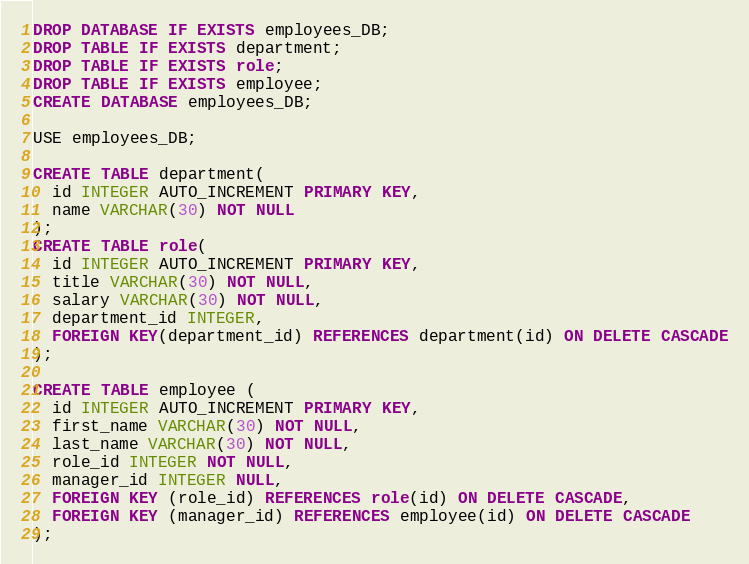<code> <loc_0><loc_0><loc_500><loc_500><_SQL_>DROP DATABASE IF EXISTS employees_DB;
DROP TABLE IF EXISTS department;
DROP TABLE IF EXISTS role;
DROP TABLE IF EXISTS employee;
CREATE DATABASE employees_DB;

USE employees_DB;

CREATE TABLE department(
  id INTEGER AUTO_INCREMENT PRIMARY KEY,
  name VARCHAR(30) NOT NULL
);
CREATE TABLE role(
  id INTEGER AUTO_INCREMENT PRIMARY KEY,
  title VARCHAR(30) NOT NULL,
  salary VARCHAR(30) NOT NULL,
  department_id INTEGER,
  FOREIGN KEY(department_id) REFERENCES department(id) ON DELETE CASCADE
);

CREATE TABLE employee (
  id INTEGER AUTO_INCREMENT PRIMARY KEY,
  first_name VARCHAR(30) NOT NULL,
  last_name VARCHAR(30) NOT NULL,
  role_id INTEGER NOT NULL,
  manager_id INTEGER NULL,
  FOREIGN KEY (role_id) REFERENCES role(id) ON DELETE CASCADE,
  FOREIGN KEY (manager_id) REFERENCES employee(id) ON DELETE CASCADE
);
</code> 